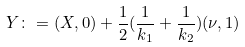Convert formula to latex. <formula><loc_0><loc_0><loc_500><loc_500>Y \colon = ( X , 0 ) + \frac { 1 } { 2 } ( \frac { 1 } { k _ { 1 } } + \frac { 1 } { k _ { 2 } } ) ( \nu , 1 )</formula> 